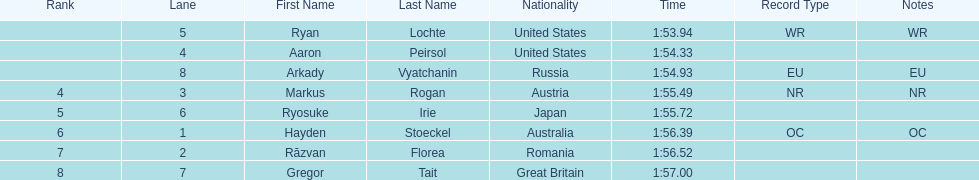Which country had the most medals in the competition? United States. 